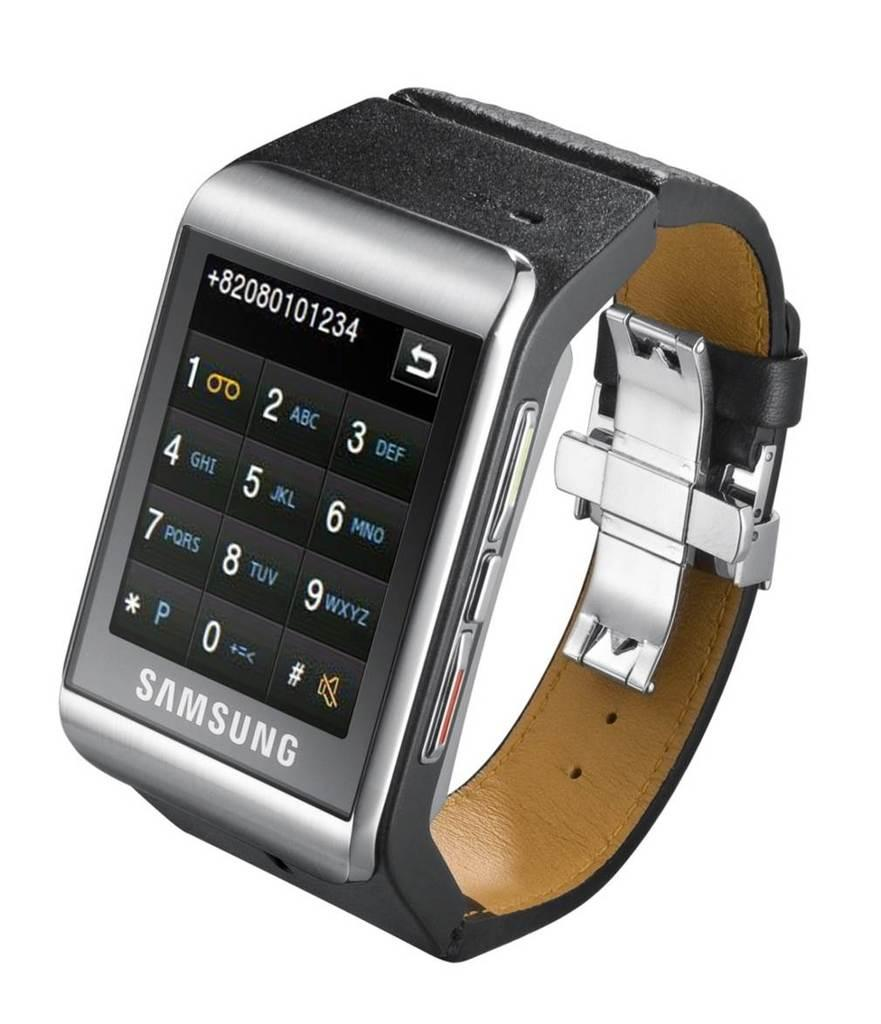<image>
Give a short and clear explanation of the subsequent image. A Samsung watch is dialing a phone number. 